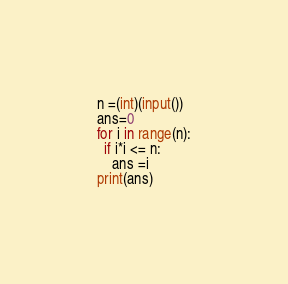Convert code to text. <code><loc_0><loc_0><loc_500><loc_500><_Python_>n =(int)(input())
ans=0
for i in range(n):
  if i*i <= n:
    ans =i
print(ans)</code> 